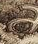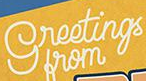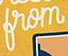Read the text from these images in sequence, separated by a semicolon. a; greetings; from 